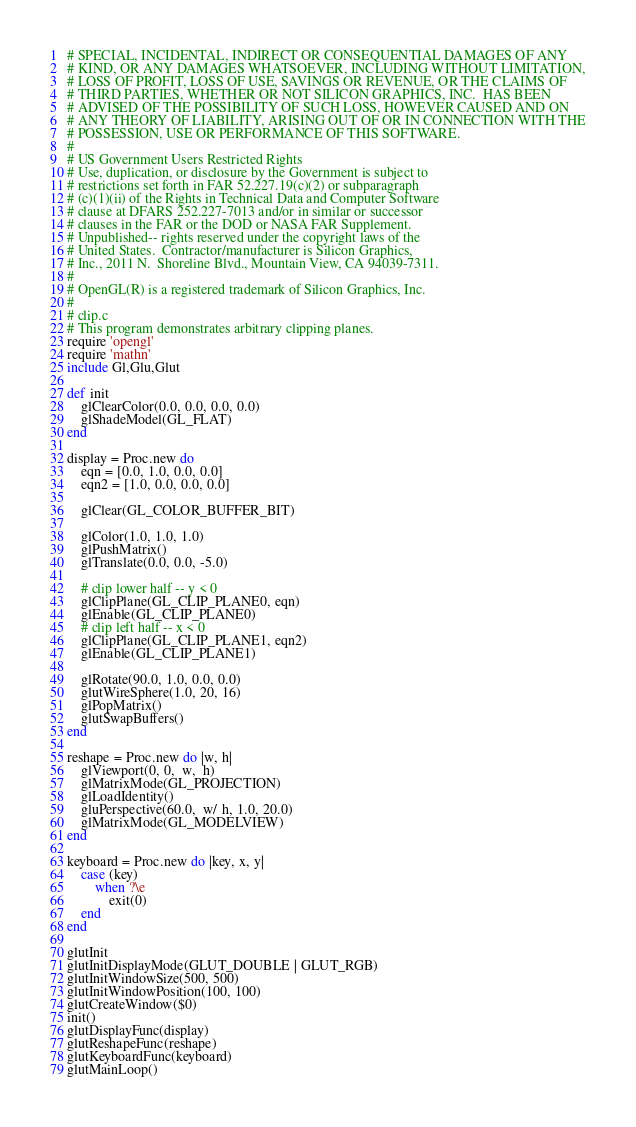Convert code to text. <code><loc_0><loc_0><loc_500><loc_500><_Ruby_># SPECIAL, INCIDENTAL, INDIRECT OR CONSEQUENTIAL DAMAGES OF ANY
# KIND, OR ANY DAMAGES WHATSOEVER, INCLUDING WITHOUT LIMITATION,
# LOSS OF PROFIT, LOSS OF USE, SAVINGS OR REVENUE, OR THE CLAIMS OF
# THIRD PARTIES, WHETHER OR NOT SILICON GRAPHICS, INC.  HAS BEEN
# ADVISED OF THE POSSIBILITY OF SUCH LOSS, HOWEVER CAUSED AND ON
# ANY THEORY OF LIABILITY, ARISING OUT OF OR IN CONNECTION WITH THE
# POSSESSION, USE OR PERFORMANCE OF THIS SOFTWARE.
# 
# US Government Users Restricted Rights 
# Use, duplication, or disclosure by the Government is subject to
# restrictions set forth in FAR 52.227.19(c)(2) or subparagraph
# (c)(1)(ii) of the Rights in Technical Data and Computer Software
# clause at DFARS 252.227-7013 and/or in similar or successor
# clauses in the FAR or the DOD or NASA FAR Supplement.
# Unpublished-- rights reserved under the copyright laws of the
# United States.  Contractor/manufacturer is Silicon Graphics,
# Inc., 2011 N.  Shoreline Blvd., Mountain View, CA 94039-7311.
#
# OpenGL(R) is a registered trademark of Silicon Graphics, Inc.
#
# clip.c
# This program demonstrates arbitrary clipping planes.
require 'opengl'
require 'mathn'
include Gl,Glu,Glut

def init
	glClearColor(0.0, 0.0, 0.0, 0.0)
	glShadeModel(GL_FLAT)
end

display = Proc.new do
	eqn = [0.0, 1.0, 0.0, 0.0]
	eqn2 = [1.0, 0.0, 0.0, 0.0]
	
	glClear(GL_COLOR_BUFFER_BIT)
	
	glColor(1.0, 1.0, 1.0)
	glPushMatrix()
	glTranslate(0.0, 0.0, -5.0)
	
	# clip lower half -- y < 0
	glClipPlane(GL_CLIP_PLANE0, eqn)
	glEnable(GL_CLIP_PLANE0)
	# clip left half -- x < 0
	glClipPlane(GL_CLIP_PLANE1, eqn2)
	glEnable(GL_CLIP_PLANE1)
	
	glRotate(90.0, 1.0, 0.0, 0.0)
	glutWireSphere(1.0, 20, 16)
	glPopMatrix()
	glutSwapBuffers()
end

reshape = Proc.new do |w, h|
	glViewport(0, 0,  w,  h) 
	glMatrixMode(GL_PROJECTION)
	glLoadIdentity()
	gluPerspective(60.0,  w/ h, 1.0, 20.0)
	glMatrixMode(GL_MODELVIEW)
end

keyboard = Proc.new do |key, x, y|
	case (key)
		when ?\e
			exit(0)
	end
end

glutInit
glutInitDisplayMode(GLUT_DOUBLE | GLUT_RGB)
glutInitWindowSize(500, 500) 
glutInitWindowPosition(100, 100)
glutCreateWindow($0)
init()
glutDisplayFunc(display) 
glutReshapeFunc(reshape)
glutKeyboardFunc(keyboard)
glutMainLoop()
</code> 